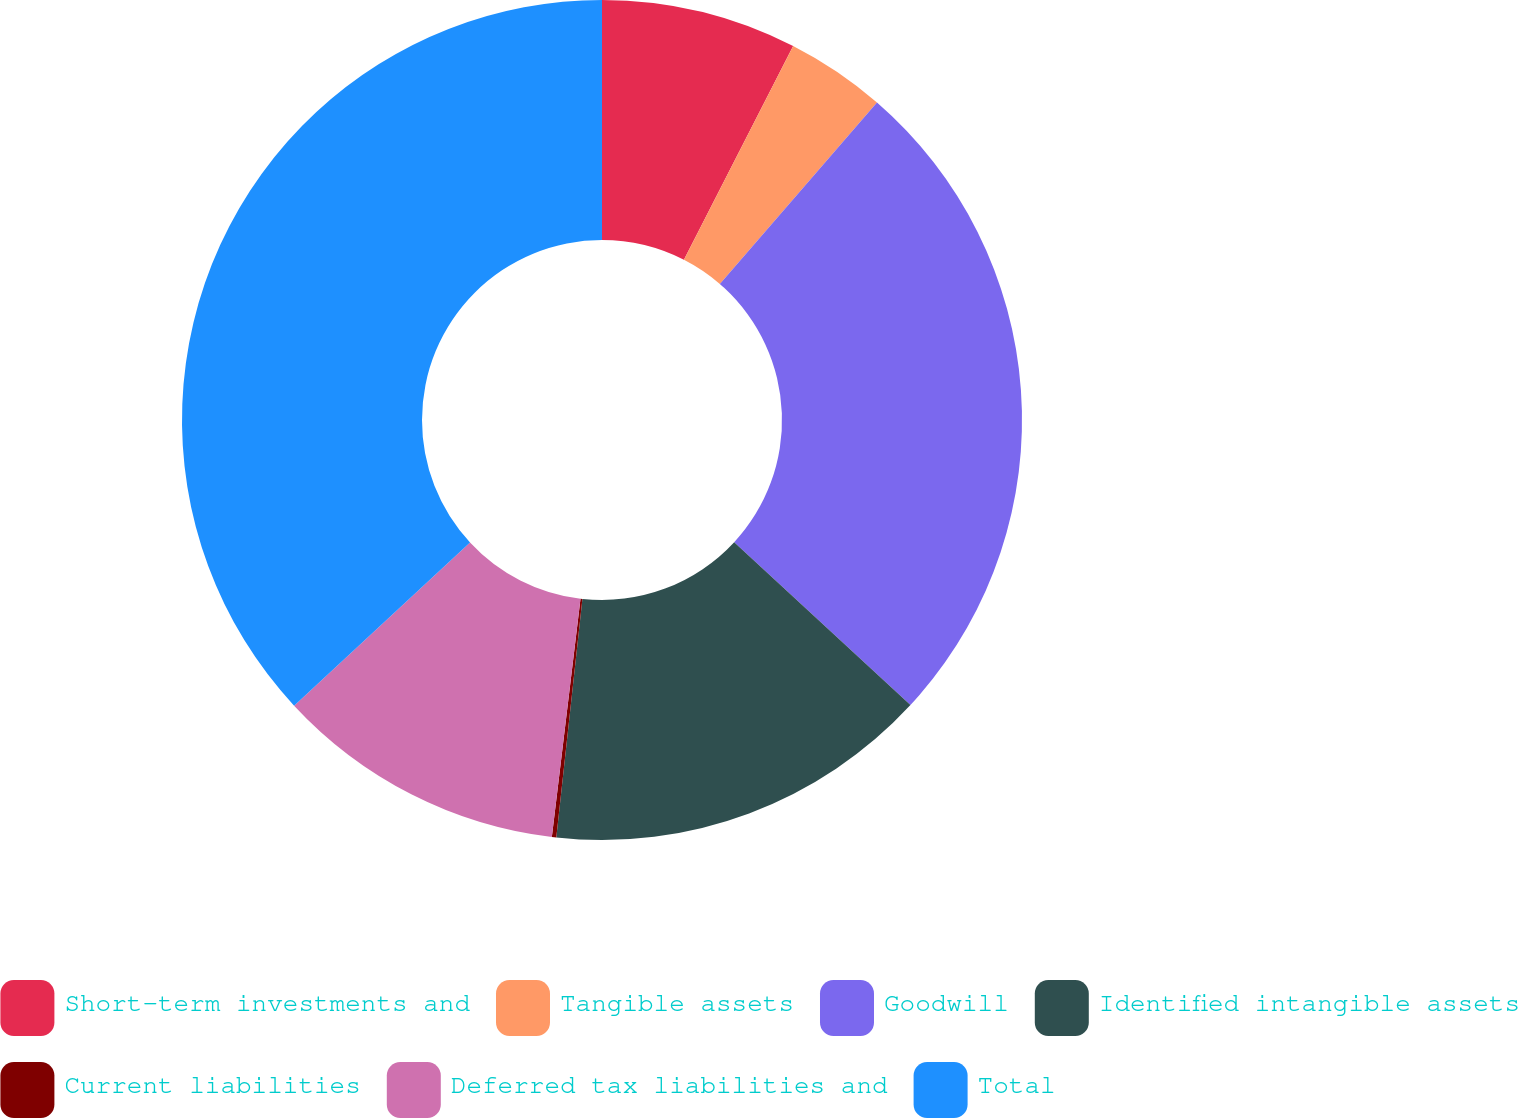Convert chart. <chart><loc_0><loc_0><loc_500><loc_500><pie_chart><fcel>Short-term investments and<fcel>Tangible assets<fcel>Goodwill<fcel>Identified intangible assets<fcel>Current liabilities<fcel>Deferred tax liabilities and<fcel>Total<nl><fcel>7.52%<fcel>3.84%<fcel>25.51%<fcel>14.86%<fcel>0.17%<fcel>11.19%<fcel>36.9%<nl></chart> 